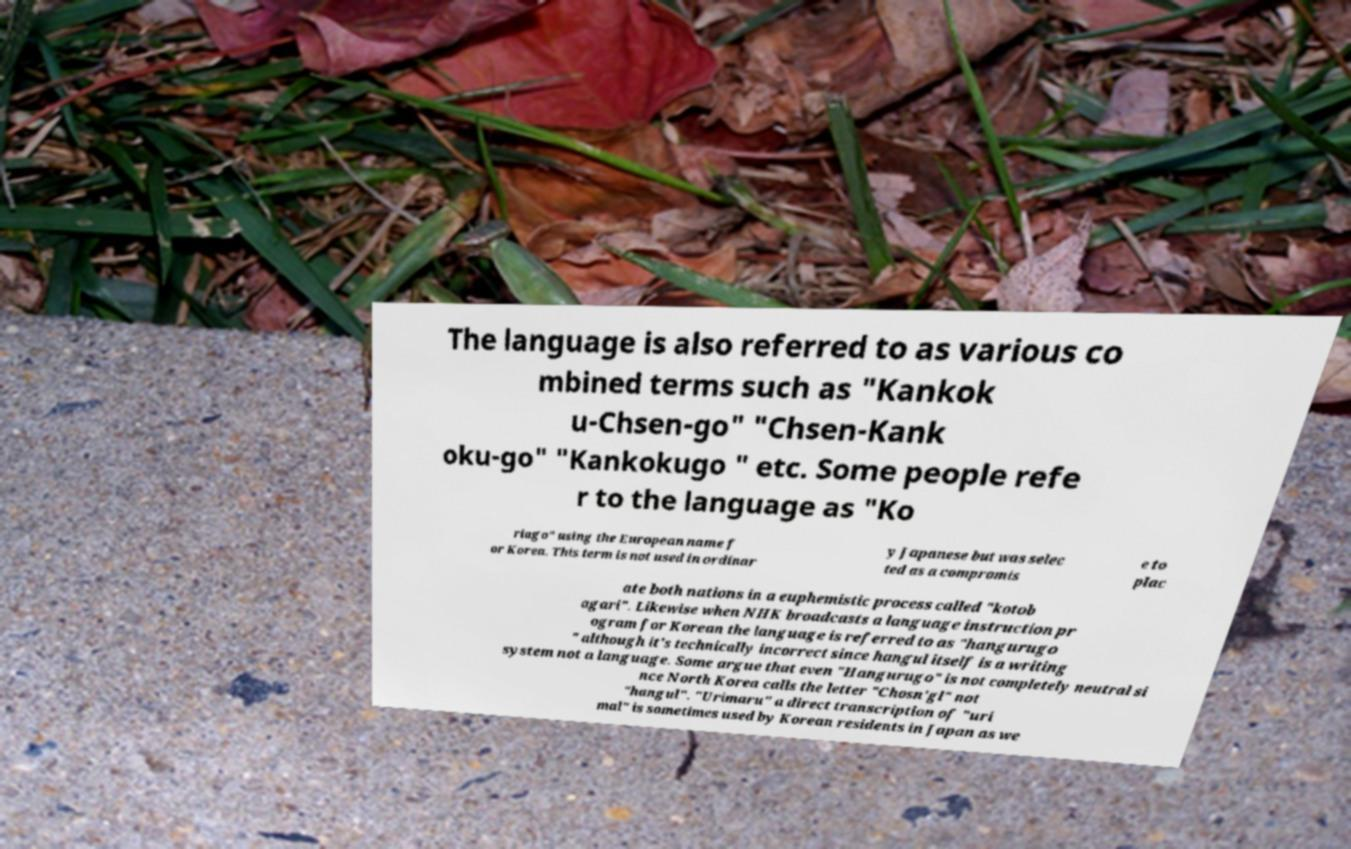Could you extract and type out the text from this image? The language is also referred to as various co mbined terms such as "Kankok u-Chsen-go" "Chsen-Kank oku-go" "Kankokugo " etc. Some people refe r to the language as "Ko riago" using the European name f or Korea. This term is not used in ordinar y Japanese but was selec ted as a compromis e to plac ate both nations in a euphemistic process called "kotob agari". Likewise when NHK broadcasts a language instruction pr ogram for Korean the language is referred to as "hangurugo " although it's technically incorrect since hangul itself is a writing system not a language. Some argue that even "Hangurugo" is not completely neutral si nce North Korea calls the letter "Chosn'gl" not "hangul". "Urimaru" a direct transcription of "uri mal" is sometimes used by Korean residents in Japan as we 